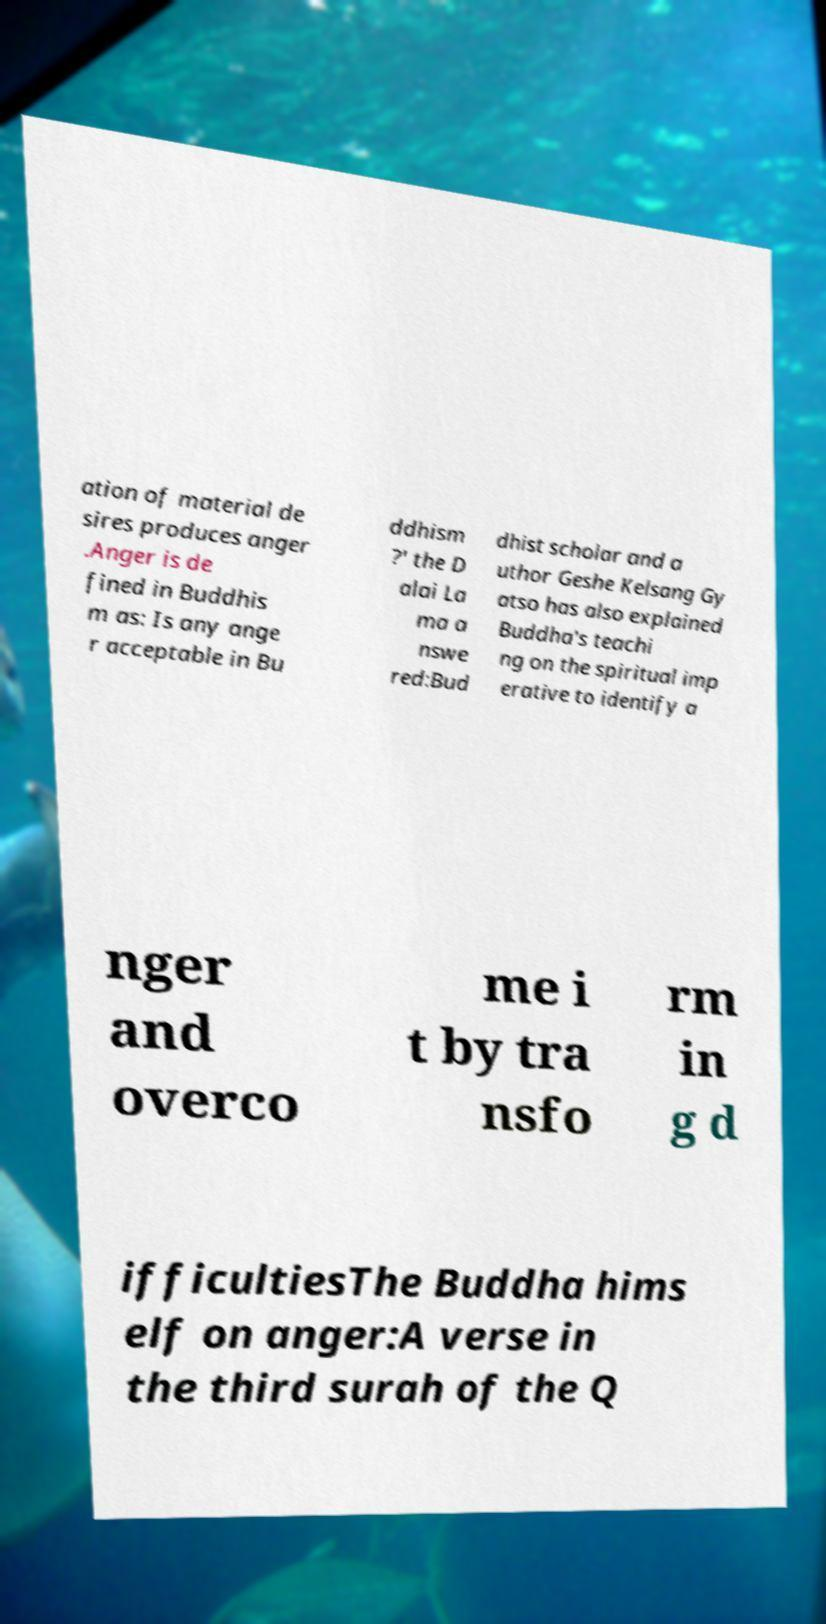Please identify and transcribe the text found in this image. ation of material de sires produces anger .Anger is de fined in Buddhis m as: Is any ange r acceptable in Bu ddhism ?' the D alai La ma a nswe red:Bud dhist scholar and a uthor Geshe Kelsang Gy atso has also explained Buddha's teachi ng on the spiritual imp erative to identify a nger and overco me i t by tra nsfo rm in g d ifficultiesThe Buddha hims elf on anger:A verse in the third surah of the Q 